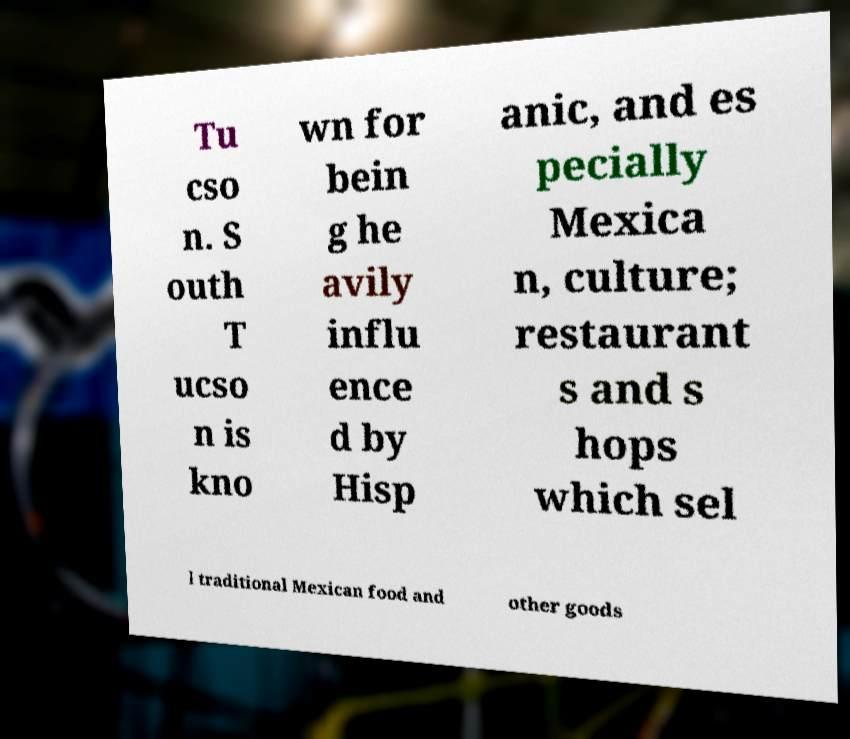There's text embedded in this image that I need extracted. Can you transcribe it verbatim? Tu cso n. S outh T ucso n is kno wn for bein g he avily influ ence d by Hisp anic, and es pecially Mexica n, culture; restaurant s and s hops which sel l traditional Mexican food and other goods 